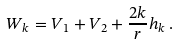<formula> <loc_0><loc_0><loc_500><loc_500>W _ { k } = V _ { 1 } + V _ { 2 } + \frac { 2 k } { r } h _ { k } \, .</formula> 